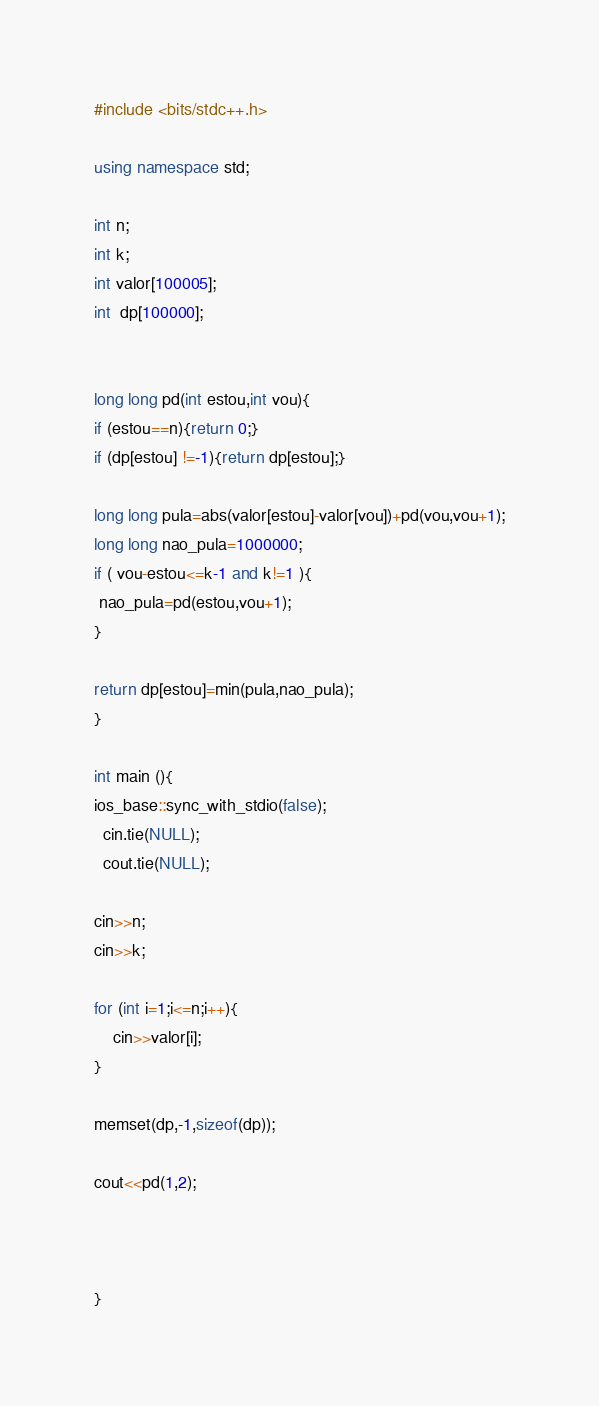Convert code to text. <code><loc_0><loc_0><loc_500><loc_500><_C++_>#include <bits/stdc++.h>

using namespace std;

int n;
int k;
int valor[100005];
int  dp[100000];


long long pd(int estou,int vou){
if (estou==n){return 0;}
if (dp[estou] !=-1){return dp[estou];}

long long pula=abs(valor[estou]-valor[vou])+pd(vou,vou+1);
long long nao_pula=1000000;
if ( vou-estou<=k-1 and k!=1 ){
 nao_pula=pd(estou,vou+1);
}

return dp[estou]=min(pula,nao_pula);
}

int main (){
ios_base::sync_with_stdio(false);
  cin.tie(NULL);
  cout.tie(NULL);

cin>>n;
cin>>k;

for (int i=1;i<=n;i++){
    cin>>valor[i];
}

memset(dp,-1,sizeof(dp));

cout<<pd(1,2);



}
</code> 